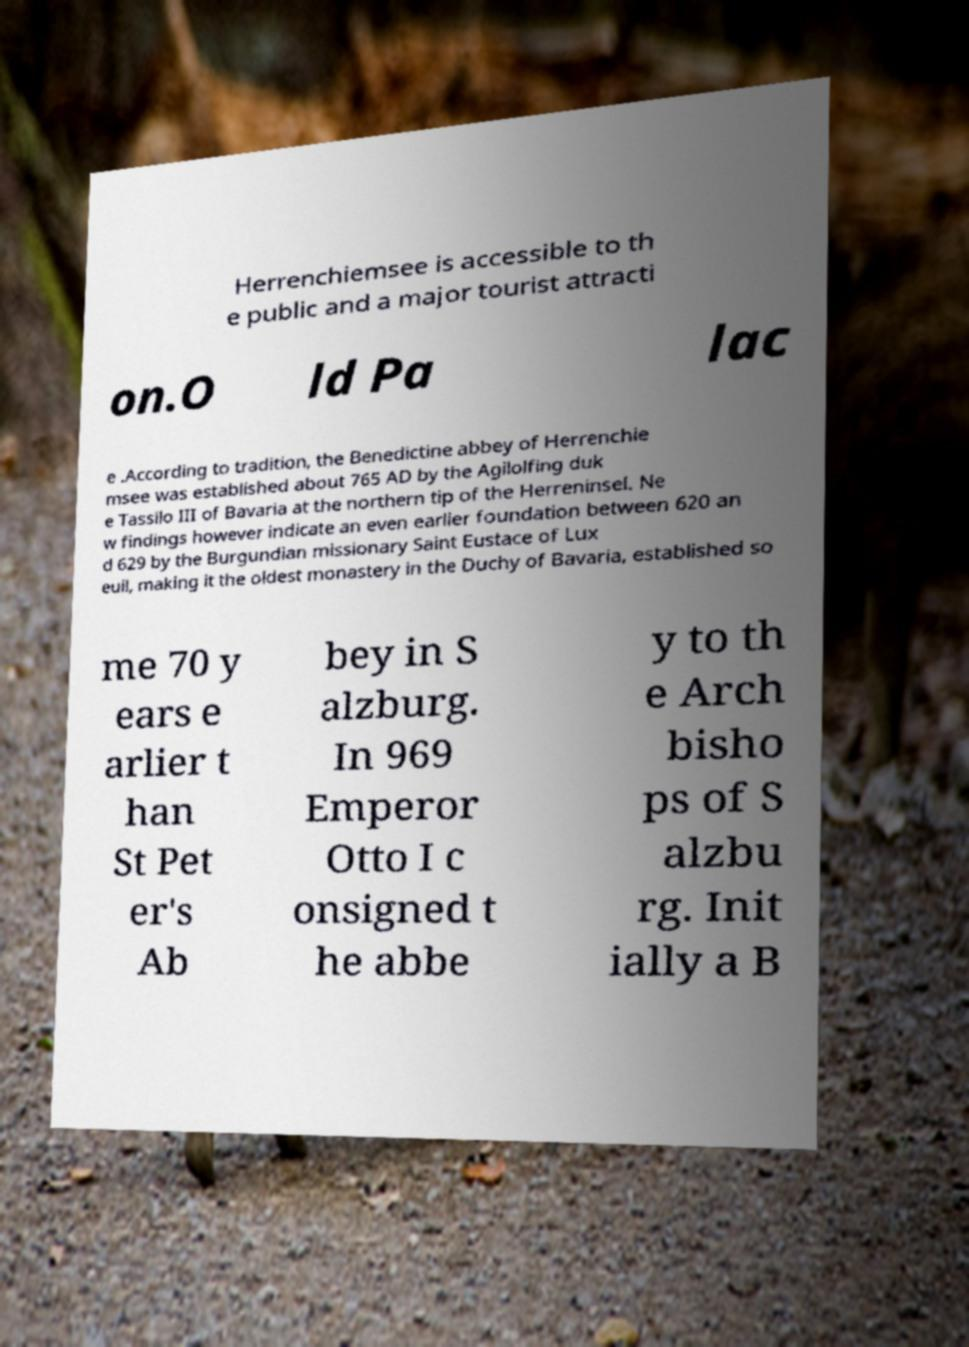For documentation purposes, I need the text within this image transcribed. Could you provide that? Herrenchiemsee is accessible to th e public and a major tourist attracti on.O ld Pa lac e .According to tradition, the Benedictine abbey of Herrenchie msee was established about 765 AD by the Agilolfing duk e Tassilo III of Bavaria at the northern tip of the Herreninsel. Ne w findings however indicate an even earlier foundation between 620 an d 629 by the Burgundian missionary Saint Eustace of Lux euil, making it the oldest monastery in the Duchy of Bavaria, established so me 70 y ears e arlier t han St Pet er's Ab bey in S alzburg. In 969 Emperor Otto I c onsigned t he abbe y to th e Arch bisho ps of S alzbu rg. Init ially a B 